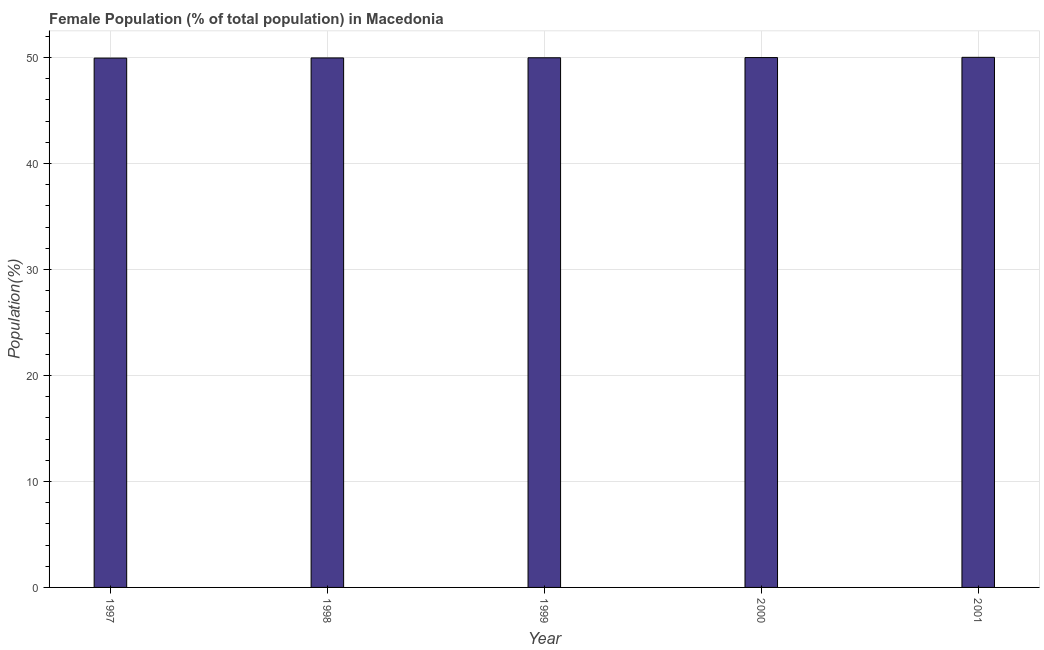Does the graph contain any zero values?
Give a very brief answer. No. Does the graph contain grids?
Provide a short and direct response. Yes. What is the title of the graph?
Your response must be concise. Female Population (% of total population) in Macedonia. What is the label or title of the Y-axis?
Make the answer very short. Population(%). What is the female population in 2000?
Ensure brevity in your answer.  50. Across all years, what is the maximum female population?
Your answer should be very brief. 50.02. Across all years, what is the minimum female population?
Offer a terse response. 49.95. In which year was the female population maximum?
Your answer should be very brief. 2001. In which year was the female population minimum?
Offer a very short reply. 1997. What is the sum of the female population?
Provide a short and direct response. 249.92. What is the difference between the female population in 1997 and 2000?
Give a very brief answer. -0.05. What is the average female population per year?
Provide a short and direct response. 49.98. What is the median female population?
Provide a succinct answer. 49.98. What is the ratio of the female population in 1999 to that in 2001?
Give a very brief answer. 1. Is the female population in 1997 less than that in 1998?
Ensure brevity in your answer.  Yes. Is the difference between the female population in 1999 and 2000 greater than the difference between any two years?
Offer a very short reply. No. What is the difference between the highest and the second highest female population?
Offer a terse response. 0.02. What is the difference between the highest and the lowest female population?
Make the answer very short. 0.07. How many bars are there?
Your answer should be very brief. 5. What is the difference between two consecutive major ticks on the Y-axis?
Provide a short and direct response. 10. Are the values on the major ticks of Y-axis written in scientific E-notation?
Your answer should be very brief. No. What is the Population(%) in 1997?
Keep it short and to the point. 49.95. What is the Population(%) of 1998?
Make the answer very short. 49.97. What is the Population(%) of 1999?
Provide a succinct answer. 49.98. What is the Population(%) in 2000?
Ensure brevity in your answer.  50. What is the Population(%) of 2001?
Give a very brief answer. 50.02. What is the difference between the Population(%) in 1997 and 1998?
Your response must be concise. -0.02. What is the difference between the Population(%) in 1997 and 1999?
Provide a succinct answer. -0.03. What is the difference between the Population(%) in 1997 and 2000?
Provide a succinct answer. -0.05. What is the difference between the Population(%) in 1997 and 2001?
Keep it short and to the point. -0.07. What is the difference between the Population(%) in 1998 and 1999?
Offer a terse response. -0.02. What is the difference between the Population(%) in 1998 and 2000?
Provide a succinct answer. -0.03. What is the difference between the Population(%) in 1998 and 2001?
Keep it short and to the point. -0.06. What is the difference between the Population(%) in 1999 and 2000?
Keep it short and to the point. -0.02. What is the difference between the Population(%) in 1999 and 2001?
Offer a very short reply. -0.04. What is the difference between the Population(%) in 2000 and 2001?
Your response must be concise. -0.02. What is the ratio of the Population(%) in 1997 to that in 1998?
Your answer should be very brief. 1. What is the ratio of the Population(%) in 1997 to that in 1999?
Your answer should be very brief. 1. What is the ratio of the Population(%) in 1997 to that in 2000?
Offer a terse response. 1. What is the ratio of the Population(%) in 1997 to that in 2001?
Ensure brevity in your answer.  1. What is the ratio of the Population(%) in 1998 to that in 1999?
Your response must be concise. 1. What is the ratio of the Population(%) in 1998 to that in 2001?
Keep it short and to the point. 1. What is the ratio of the Population(%) in 1999 to that in 2000?
Give a very brief answer. 1. What is the ratio of the Population(%) in 1999 to that in 2001?
Provide a short and direct response. 1. What is the ratio of the Population(%) in 2000 to that in 2001?
Provide a short and direct response. 1. 